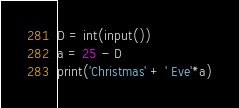Convert code to text. <code><loc_0><loc_0><loc_500><loc_500><_Python_>D = int(input())
a = 25 - D
print('Christmas' + ' Eve'*a)</code> 